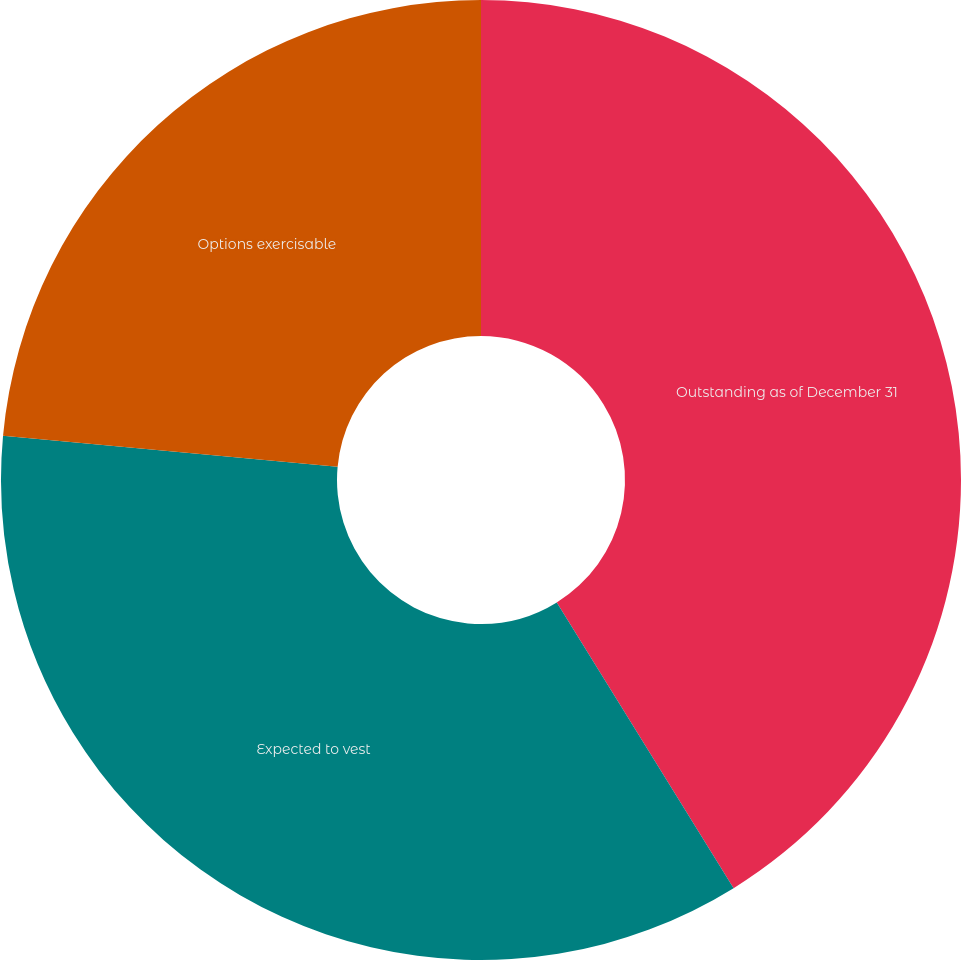Convert chart to OTSL. <chart><loc_0><loc_0><loc_500><loc_500><pie_chart><fcel>Outstanding as of December 31<fcel>Expected to vest<fcel>Options exercisable<nl><fcel>41.18%<fcel>35.29%<fcel>23.53%<nl></chart> 